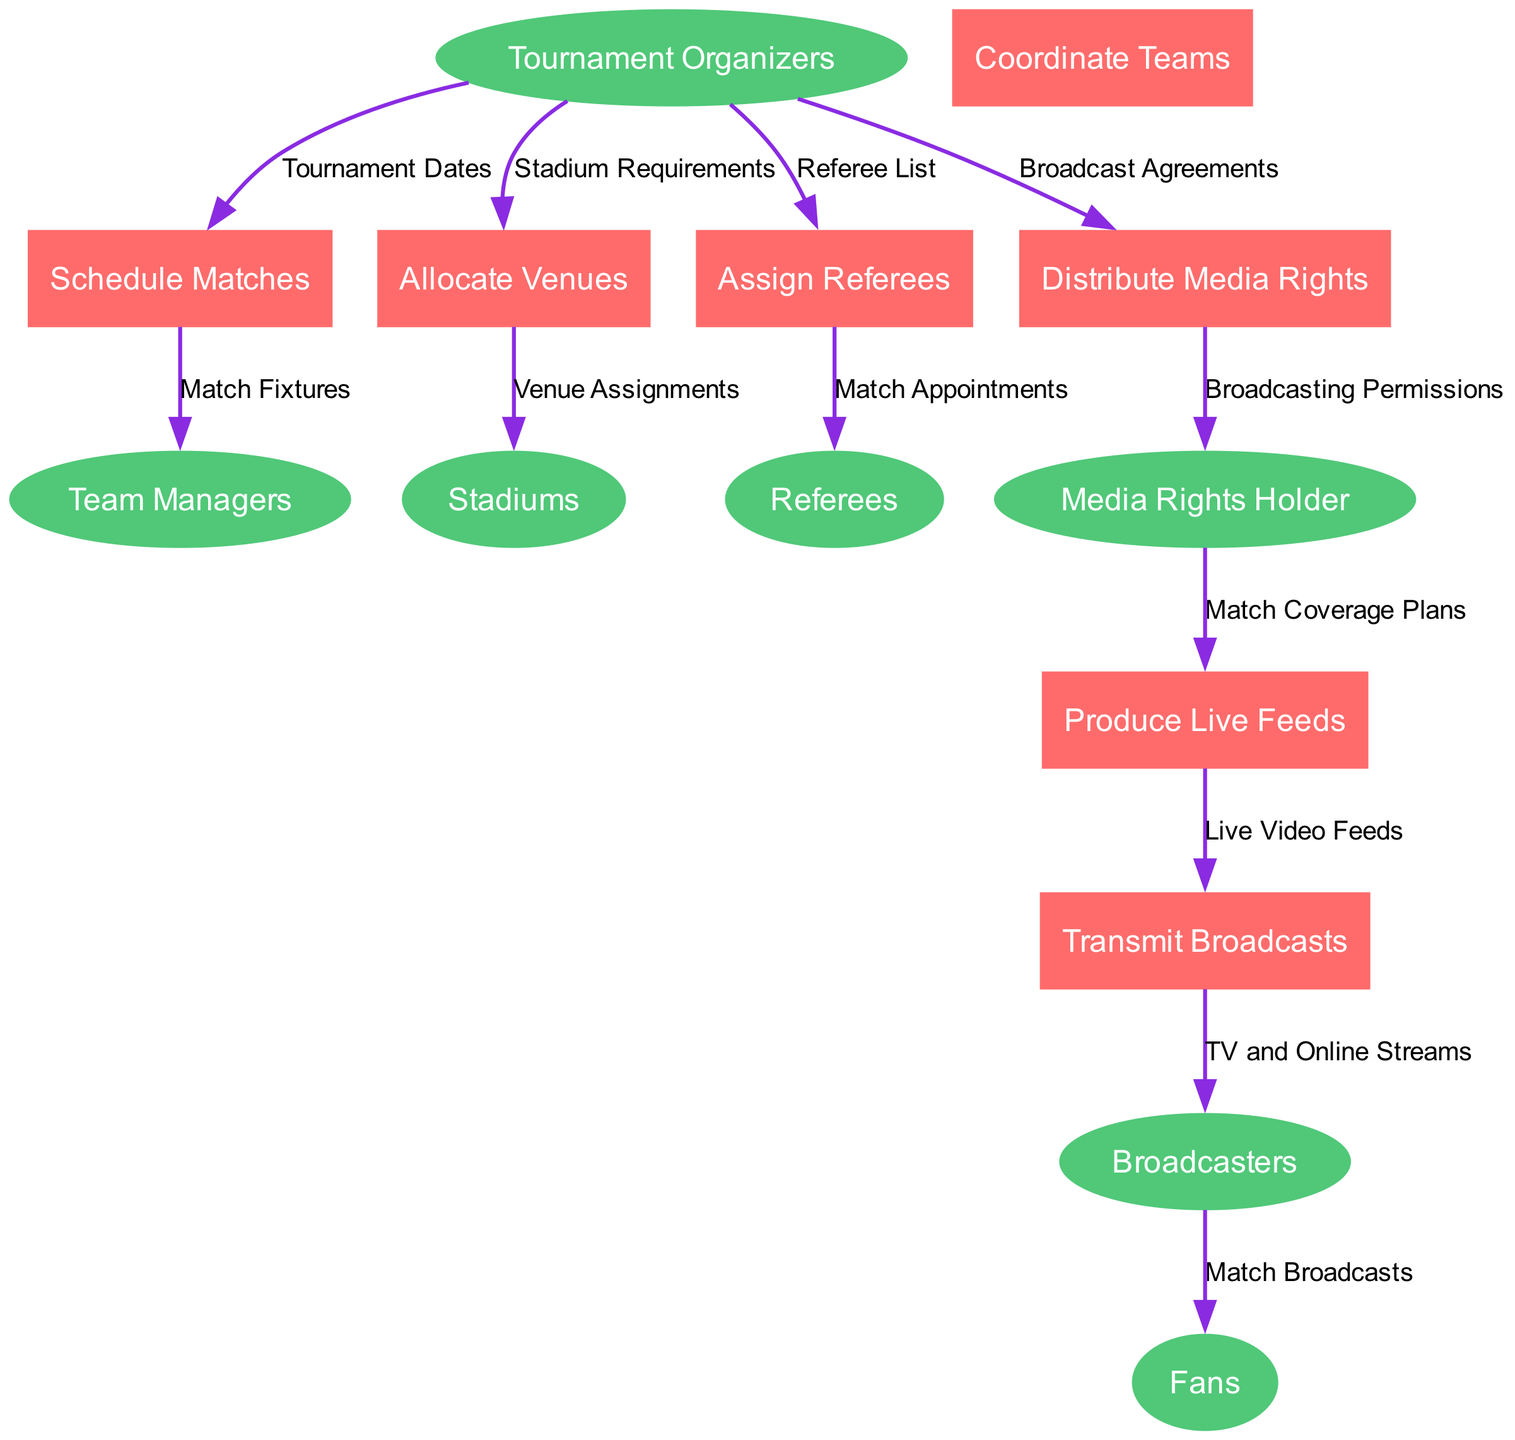What are the entities involved in the diagram? The entities in the diagram are Tournament Organizers, Team Managers, Media Rights Holder, Broadcasters, Stadiums, Referees, and Fans. They are represented as the primary actors in the process flow.
Answer: Tournament Organizers, Team Managers, Media Rights Holder, Broadcasters, Stadiums, Referees, Fans How many processes are depicted in the diagram? The diagram contains seven processes, each representing a key activity involved in organizing and broadcasting the tournament, which are listed in the processes section.
Answer: Seven What data flows from Team Managers to Schedule Matches? The data flowing from Team Managers to Schedule Matches is Match Fixtures. This indicates that Team Managers receive match timings and arrangements derived from the scheduling process.
Answer: Match Fixtures Which entity receives transmissions of broadcasts? Fans receive the transmissions of broadcasts. This is the final destination for the broadcast data, indicating the target audience for the match coverage.
Answer: Fans How is match coverage planned and executed according to the diagram? The process starts with Media Rights Holder receiving Match Coverage Plans from the Tournament Organizers, allowing them to Produce Live Feeds, which are ultimately Transmitted to Broadcasters. This shows a sequence of preparation and transmission steps for broadcast content.
Answer: Match Coverage Plans Which process is responsible for allocating venues? The process responsible for allocating venues is named Allocate Venues. It receives information from the Tournament Organizers and sends Venue Assignments to the Stadiums involved in the tournament.
Answer: Allocate Venues What information do referees receive from the Assign Referees process? Referees receive Match Appointments from the Assign Referees process. This information details which referees are assigned to officiate specific matches during the tournament.
Answer: Match Appointments What is the relationship between Produce Live Feeds and Transmit Broadcasts? The relationship is sequential; Produce Live Feeds outputs Live Video Feeds, which then serve as input for Transmit Broadcasts. This indicates that live footage production directly precedes the broadcasting process.
Answer: Live Video Feeds In total, how many data flows originate from the Tournament Organizers? A total of five data flows originate from the Tournament Organizers. This shows their central role in distributing crucial information necessary for successfully managing the tournament.
Answer: Five 